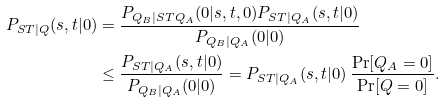<formula> <loc_0><loc_0><loc_500><loc_500>P _ { S T | Q } ( s , t | 0 ) & = \frac { P _ { Q _ { B } | S T Q _ { A } } ( 0 | s , t , 0 ) P _ { S T | Q _ { A } } ( s , t | 0 ) } { P _ { Q _ { B } | Q _ { A } } ( 0 | 0 ) } \\ & \leq \frac { P _ { S T | Q _ { A } } ( s , t | 0 ) } { P _ { Q _ { B } | Q _ { A } } ( 0 | 0 ) } = P _ { S T | Q _ { A } } ( s , t | 0 ) \, \frac { \Pr [ Q _ { A } = 0 ] } { \Pr [ Q = 0 ] } .</formula> 